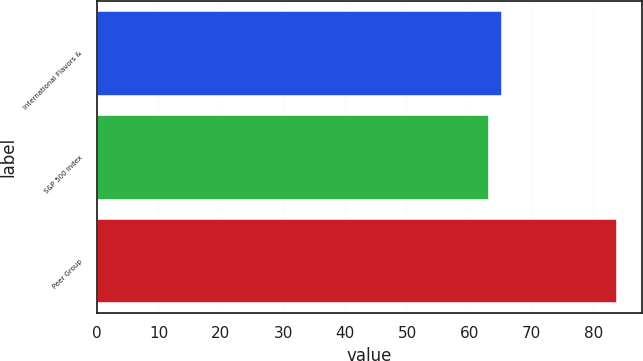<chart> <loc_0><loc_0><loc_500><loc_500><bar_chart><fcel>International Flavors &<fcel>S&P 500 Index<fcel>Peer Group<nl><fcel>65.07<fcel>63<fcel>83.68<nl></chart> 